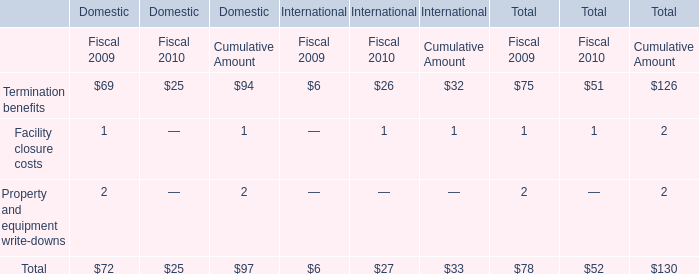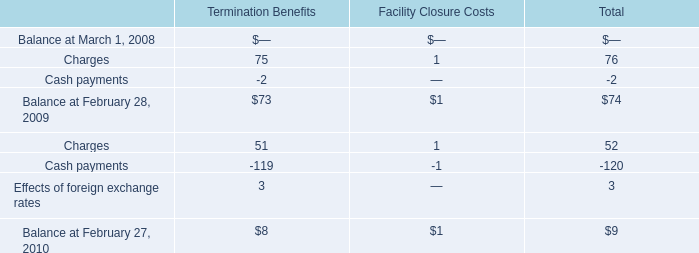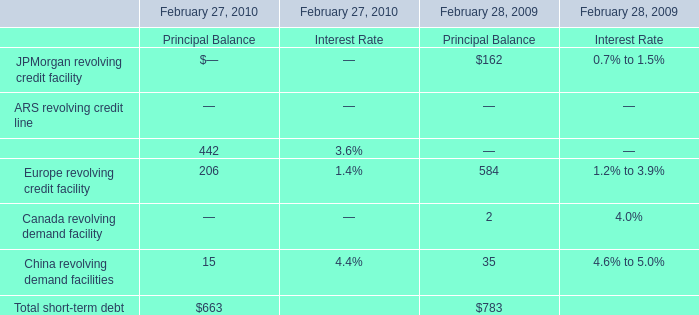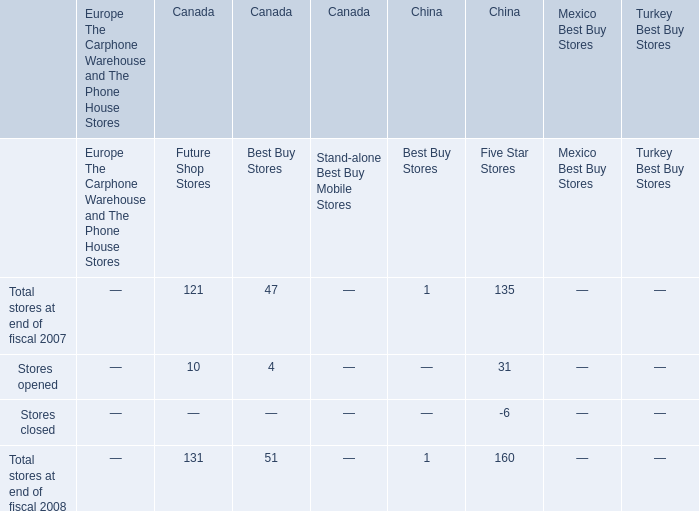What's the growth rate of Europe revolving credit facility in 2010? 
Computations: ((206 - 584) / 584)
Answer: -0.64726. 